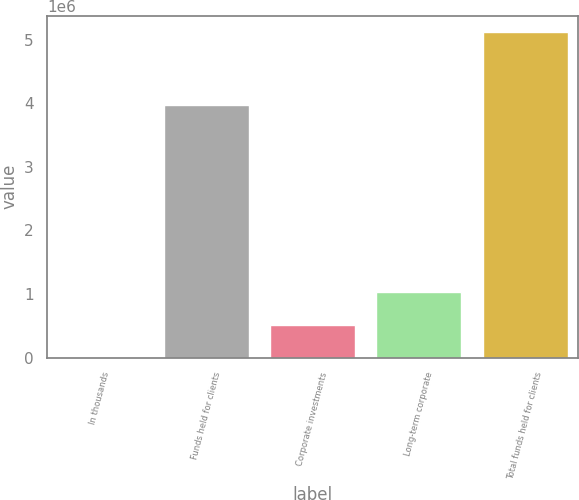Convert chart. <chart><loc_0><loc_0><loc_500><loc_500><bar_chart><fcel>In thousands<fcel>Funds held for clients<fcel>Corporate investments<fcel>Long-term corporate<fcel>Total funds held for clients<nl><fcel>2007<fcel>3.9731e+06<fcel>513602<fcel>1.0252e+06<fcel>5.11796e+06<nl></chart> 